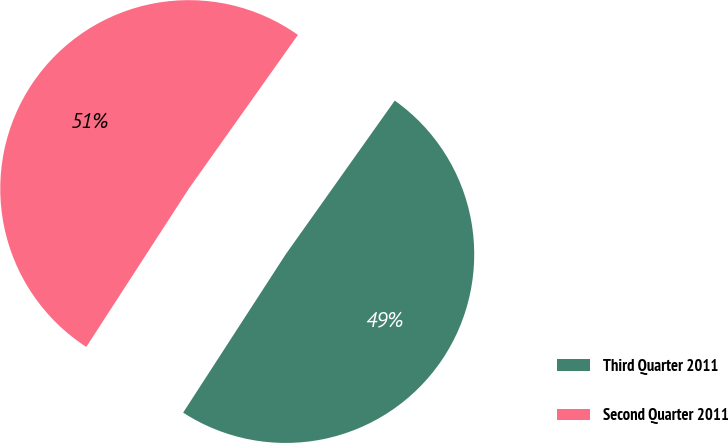Convert chart. <chart><loc_0><loc_0><loc_500><loc_500><pie_chart><fcel>Third Quarter 2011<fcel>Second Quarter 2011<nl><fcel>49.33%<fcel>50.67%<nl></chart> 